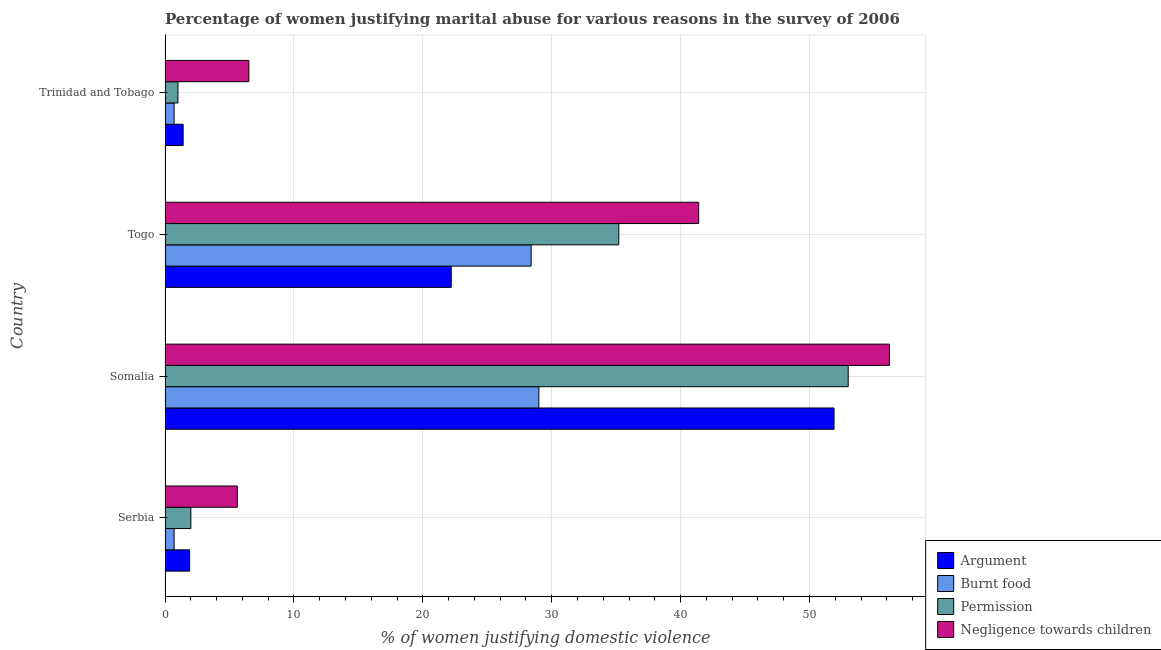How many groups of bars are there?
Keep it short and to the point. 4. How many bars are there on the 1st tick from the top?
Give a very brief answer. 4. How many bars are there on the 2nd tick from the bottom?
Your answer should be compact. 4. What is the label of the 4th group of bars from the top?
Ensure brevity in your answer.  Serbia. What is the percentage of women justifying abuse in the case of an argument in Somalia?
Offer a terse response. 51.9. Across all countries, what is the maximum percentage of women justifying abuse for burning food?
Keep it short and to the point. 29. In which country was the percentage of women justifying abuse in the case of an argument maximum?
Offer a terse response. Somalia. In which country was the percentage of women justifying abuse for showing negligence towards children minimum?
Your answer should be very brief. Serbia. What is the total percentage of women justifying abuse for showing negligence towards children in the graph?
Provide a short and direct response. 109.7. What is the difference between the percentage of women justifying abuse for burning food in Somalia and that in Trinidad and Tobago?
Provide a short and direct response. 28.3. What is the difference between the percentage of women justifying abuse for showing negligence towards children in Somalia and the percentage of women justifying abuse in the case of an argument in Togo?
Your response must be concise. 34. What is the average percentage of women justifying abuse for burning food per country?
Provide a short and direct response. 14.7. Is the percentage of women justifying abuse for going without permission in Togo less than that in Trinidad and Tobago?
Offer a very short reply. No. What is the difference between the highest and the lowest percentage of women justifying abuse in the case of an argument?
Provide a succinct answer. 50.5. In how many countries, is the percentage of women justifying abuse for showing negligence towards children greater than the average percentage of women justifying abuse for showing negligence towards children taken over all countries?
Ensure brevity in your answer.  2. Is it the case that in every country, the sum of the percentage of women justifying abuse for going without permission and percentage of women justifying abuse for burning food is greater than the sum of percentage of women justifying abuse in the case of an argument and percentage of women justifying abuse for showing negligence towards children?
Your answer should be compact. No. What does the 4th bar from the top in Trinidad and Tobago represents?
Keep it short and to the point. Argument. What does the 3rd bar from the bottom in Togo represents?
Make the answer very short. Permission. How many bars are there?
Your answer should be compact. 16. Are all the bars in the graph horizontal?
Give a very brief answer. Yes. How many countries are there in the graph?
Make the answer very short. 4. Does the graph contain any zero values?
Ensure brevity in your answer.  No. Does the graph contain grids?
Offer a terse response. Yes. What is the title of the graph?
Give a very brief answer. Percentage of women justifying marital abuse for various reasons in the survey of 2006. What is the label or title of the X-axis?
Your answer should be very brief. % of women justifying domestic violence. What is the % of women justifying domestic violence in Argument in Serbia?
Ensure brevity in your answer.  1.9. What is the % of women justifying domestic violence of Permission in Serbia?
Make the answer very short. 2. What is the % of women justifying domestic violence in Negligence towards children in Serbia?
Make the answer very short. 5.6. What is the % of women justifying domestic violence of Argument in Somalia?
Your response must be concise. 51.9. What is the % of women justifying domestic violence of Burnt food in Somalia?
Offer a terse response. 29. What is the % of women justifying domestic violence in Permission in Somalia?
Your answer should be compact. 53. What is the % of women justifying domestic violence of Negligence towards children in Somalia?
Provide a short and direct response. 56.2. What is the % of women justifying domestic violence in Burnt food in Togo?
Ensure brevity in your answer.  28.4. What is the % of women justifying domestic violence of Permission in Togo?
Offer a very short reply. 35.2. What is the % of women justifying domestic violence in Negligence towards children in Togo?
Keep it short and to the point. 41.4. What is the % of women justifying domestic violence of Argument in Trinidad and Tobago?
Your answer should be compact. 1.4. What is the % of women justifying domestic violence of Permission in Trinidad and Tobago?
Offer a very short reply. 1. What is the % of women justifying domestic violence of Negligence towards children in Trinidad and Tobago?
Your answer should be very brief. 6.5. Across all countries, what is the maximum % of women justifying domestic violence of Argument?
Make the answer very short. 51.9. Across all countries, what is the maximum % of women justifying domestic violence in Permission?
Give a very brief answer. 53. Across all countries, what is the maximum % of women justifying domestic violence in Negligence towards children?
Give a very brief answer. 56.2. Across all countries, what is the minimum % of women justifying domestic violence in Burnt food?
Offer a very short reply. 0.7. Across all countries, what is the minimum % of women justifying domestic violence of Permission?
Your answer should be very brief. 1. Across all countries, what is the minimum % of women justifying domestic violence of Negligence towards children?
Your answer should be compact. 5.6. What is the total % of women justifying domestic violence of Argument in the graph?
Your answer should be very brief. 77.4. What is the total % of women justifying domestic violence in Burnt food in the graph?
Provide a short and direct response. 58.8. What is the total % of women justifying domestic violence in Permission in the graph?
Ensure brevity in your answer.  91.2. What is the total % of women justifying domestic violence in Negligence towards children in the graph?
Your answer should be very brief. 109.7. What is the difference between the % of women justifying domestic violence in Argument in Serbia and that in Somalia?
Your answer should be compact. -50. What is the difference between the % of women justifying domestic violence in Burnt food in Serbia and that in Somalia?
Offer a terse response. -28.3. What is the difference between the % of women justifying domestic violence in Permission in Serbia and that in Somalia?
Your answer should be compact. -51. What is the difference between the % of women justifying domestic violence in Negligence towards children in Serbia and that in Somalia?
Make the answer very short. -50.6. What is the difference between the % of women justifying domestic violence of Argument in Serbia and that in Togo?
Offer a terse response. -20.3. What is the difference between the % of women justifying domestic violence in Burnt food in Serbia and that in Togo?
Your response must be concise. -27.7. What is the difference between the % of women justifying domestic violence of Permission in Serbia and that in Togo?
Offer a terse response. -33.2. What is the difference between the % of women justifying domestic violence in Negligence towards children in Serbia and that in Togo?
Provide a short and direct response. -35.8. What is the difference between the % of women justifying domestic violence in Burnt food in Serbia and that in Trinidad and Tobago?
Ensure brevity in your answer.  0. What is the difference between the % of women justifying domestic violence of Argument in Somalia and that in Togo?
Your answer should be compact. 29.7. What is the difference between the % of women justifying domestic violence of Burnt food in Somalia and that in Togo?
Offer a very short reply. 0.6. What is the difference between the % of women justifying domestic violence in Argument in Somalia and that in Trinidad and Tobago?
Provide a succinct answer. 50.5. What is the difference between the % of women justifying domestic violence in Burnt food in Somalia and that in Trinidad and Tobago?
Keep it short and to the point. 28.3. What is the difference between the % of women justifying domestic violence of Negligence towards children in Somalia and that in Trinidad and Tobago?
Give a very brief answer. 49.7. What is the difference between the % of women justifying domestic violence of Argument in Togo and that in Trinidad and Tobago?
Give a very brief answer. 20.8. What is the difference between the % of women justifying domestic violence in Burnt food in Togo and that in Trinidad and Tobago?
Give a very brief answer. 27.7. What is the difference between the % of women justifying domestic violence of Permission in Togo and that in Trinidad and Tobago?
Your answer should be very brief. 34.2. What is the difference between the % of women justifying domestic violence in Negligence towards children in Togo and that in Trinidad and Tobago?
Keep it short and to the point. 34.9. What is the difference between the % of women justifying domestic violence in Argument in Serbia and the % of women justifying domestic violence in Burnt food in Somalia?
Your answer should be very brief. -27.1. What is the difference between the % of women justifying domestic violence of Argument in Serbia and the % of women justifying domestic violence of Permission in Somalia?
Provide a short and direct response. -51.1. What is the difference between the % of women justifying domestic violence in Argument in Serbia and the % of women justifying domestic violence in Negligence towards children in Somalia?
Your answer should be very brief. -54.3. What is the difference between the % of women justifying domestic violence in Burnt food in Serbia and the % of women justifying domestic violence in Permission in Somalia?
Make the answer very short. -52.3. What is the difference between the % of women justifying domestic violence in Burnt food in Serbia and the % of women justifying domestic violence in Negligence towards children in Somalia?
Provide a succinct answer. -55.5. What is the difference between the % of women justifying domestic violence in Permission in Serbia and the % of women justifying domestic violence in Negligence towards children in Somalia?
Offer a terse response. -54.2. What is the difference between the % of women justifying domestic violence in Argument in Serbia and the % of women justifying domestic violence in Burnt food in Togo?
Ensure brevity in your answer.  -26.5. What is the difference between the % of women justifying domestic violence of Argument in Serbia and the % of women justifying domestic violence of Permission in Togo?
Your answer should be very brief. -33.3. What is the difference between the % of women justifying domestic violence of Argument in Serbia and the % of women justifying domestic violence of Negligence towards children in Togo?
Your response must be concise. -39.5. What is the difference between the % of women justifying domestic violence of Burnt food in Serbia and the % of women justifying domestic violence of Permission in Togo?
Ensure brevity in your answer.  -34.5. What is the difference between the % of women justifying domestic violence in Burnt food in Serbia and the % of women justifying domestic violence in Negligence towards children in Togo?
Your answer should be compact. -40.7. What is the difference between the % of women justifying domestic violence in Permission in Serbia and the % of women justifying domestic violence in Negligence towards children in Togo?
Your response must be concise. -39.4. What is the difference between the % of women justifying domestic violence in Argument in Serbia and the % of women justifying domestic violence in Negligence towards children in Trinidad and Tobago?
Provide a short and direct response. -4.6. What is the difference between the % of women justifying domestic violence in Argument in Somalia and the % of women justifying domestic violence in Burnt food in Togo?
Provide a succinct answer. 23.5. What is the difference between the % of women justifying domestic violence in Argument in Somalia and the % of women justifying domestic violence in Permission in Togo?
Offer a terse response. 16.7. What is the difference between the % of women justifying domestic violence in Burnt food in Somalia and the % of women justifying domestic violence in Permission in Togo?
Provide a short and direct response. -6.2. What is the difference between the % of women justifying domestic violence in Burnt food in Somalia and the % of women justifying domestic violence in Negligence towards children in Togo?
Offer a terse response. -12.4. What is the difference between the % of women justifying domestic violence of Permission in Somalia and the % of women justifying domestic violence of Negligence towards children in Togo?
Ensure brevity in your answer.  11.6. What is the difference between the % of women justifying domestic violence in Argument in Somalia and the % of women justifying domestic violence in Burnt food in Trinidad and Tobago?
Provide a succinct answer. 51.2. What is the difference between the % of women justifying domestic violence of Argument in Somalia and the % of women justifying domestic violence of Permission in Trinidad and Tobago?
Provide a short and direct response. 50.9. What is the difference between the % of women justifying domestic violence of Argument in Somalia and the % of women justifying domestic violence of Negligence towards children in Trinidad and Tobago?
Keep it short and to the point. 45.4. What is the difference between the % of women justifying domestic violence in Burnt food in Somalia and the % of women justifying domestic violence in Permission in Trinidad and Tobago?
Offer a terse response. 28. What is the difference between the % of women justifying domestic violence of Permission in Somalia and the % of women justifying domestic violence of Negligence towards children in Trinidad and Tobago?
Offer a terse response. 46.5. What is the difference between the % of women justifying domestic violence of Argument in Togo and the % of women justifying domestic violence of Permission in Trinidad and Tobago?
Give a very brief answer. 21.2. What is the difference between the % of women justifying domestic violence in Burnt food in Togo and the % of women justifying domestic violence in Permission in Trinidad and Tobago?
Your answer should be compact. 27.4. What is the difference between the % of women justifying domestic violence of Burnt food in Togo and the % of women justifying domestic violence of Negligence towards children in Trinidad and Tobago?
Your response must be concise. 21.9. What is the difference between the % of women justifying domestic violence of Permission in Togo and the % of women justifying domestic violence of Negligence towards children in Trinidad and Tobago?
Your answer should be compact. 28.7. What is the average % of women justifying domestic violence of Argument per country?
Provide a short and direct response. 19.35. What is the average % of women justifying domestic violence in Permission per country?
Your answer should be very brief. 22.8. What is the average % of women justifying domestic violence of Negligence towards children per country?
Keep it short and to the point. 27.43. What is the difference between the % of women justifying domestic violence of Permission and % of women justifying domestic violence of Negligence towards children in Serbia?
Ensure brevity in your answer.  -3.6. What is the difference between the % of women justifying domestic violence in Argument and % of women justifying domestic violence in Burnt food in Somalia?
Keep it short and to the point. 22.9. What is the difference between the % of women justifying domestic violence in Argument and % of women justifying domestic violence in Permission in Somalia?
Provide a succinct answer. -1.1. What is the difference between the % of women justifying domestic violence of Burnt food and % of women justifying domestic violence of Negligence towards children in Somalia?
Ensure brevity in your answer.  -27.2. What is the difference between the % of women justifying domestic violence of Permission and % of women justifying domestic violence of Negligence towards children in Somalia?
Ensure brevity in your answer.  -3.2. What is the difference between the % of women justifying domestic violence of Argument and % of women justifying domestic violence of Burnt food in Togo?
Offer a very short reply. -6.2. What is the difference between the % of women justifying domestic violence of Argument and % of women justifying domestic violence of Negligence towards children in Togo?
Ensure brevity in your answer.  -19.2. What is the difference between the % of women justifying domestic violence in Burnt food and % of women justifying domestic violence in Permission in Togo?
Your response must be concise. -6.8. What is the difference between the % of women justifying domestic violence of Burnt food and % of women justifying domestic violence of Negligence towards children in Togo?
Provide a short and direct response. -13. What is the difference between the % of women justifying domestic violence in Permission and % of women justifying domestic violence in Negligence towards children in Togo?
Your answer should be very brief. -6.2. What is the difference between the % of women justifying domestic violence of Argument and % of women justifying domestic violence of Burnt food in Trinidad and Tobago?
Give a very brief answer. 0.7. What is the difference between the % of women justifying domestic violence in Argument and % of women justifying domestic violence in Permission in Trinidad and Tobago?
Give a very brief answer. 0.4. What is the difference between the % of women justifying domestic violence in Permission and % of women justifying domestic violence in Negligence towards children in Trinidad and Tobago?
Provide a succinct answer. -5.5. What is the ratio of the % of women justifying domestic violence in Argument in Serbia to that in Somalia?
Offer a terse response. 0.04. What is the ratio of the % of women justifying domestic violence in Burnt food in Serbia to that in Somalia?
Ensure brevity in your answer.  0.02. What is the ratio of the % of women justifying domestic violence of Permission in Serbia to that in Somalia?
Your answer should be compact. 0.04. What is the ratio of the % of women justifying domestic violence in Negligence towards children in Serbia to that in Somalia?
Provide a short and direct response. 0.1. What is the ratio of the % of women justifying domestic violence in Argument in Serbia to that in Togo?
Provide a short and direct response. 0.09. What is the ratio of the % of women justifying domestic violence in Burnt food in Serbia to that in Togo?
Your answer should be very brief. 0.02. What is the ratio of the % of women justifying domestic violence of Permission in Serbia to that in Togo?
Provide a short and direct response. 0.06. What is the ratio of the % of women justifying domestic violence in Negligence towards children in Serbia to that in Togo?
Make the answer very short. 0.14. What is the ratio of the % of women justifying domestic violence in Argument in Serbia to that in Trinidad and Tobago?
Your answer should be compact. 1.36. What is the ratio of the % of women justifying domestic violence in Permission in Serbia to that in Trinidad and Tobago?
Offer a terse response. 2. What is the ratio of the % of women justifying domestic violence in Negligence towards children in Serbia to that in Trinidad and Tobago?
Provide a succinct answer. 0.86. What is the ratio of the % of women justifying domestic violence of Argument in Somalia to that in Togo?
Offer a very short reply. 2.34. What is the ratio of the % of women justifying domestic violence of Burnt food in Somalia to that in Togo?
Give a very brief answer. 1.02. What is the ratio of the % of women justifying domestic violence in Permission in Somalia to that in Togo?
Keep it short and to the point. 1.51. What is the ratio of the % of women justifying domestic violence of Negligence towards children in Somalia to that in Togo?
Keep it short and to the point. 1.36. What is the ratio of the % of women justifying domestic violence of Argument in Somalia to that in Trinidad and Tobago?
Your answer should be compact. 37.07. What is the ratio of the % of women justifying domestic violence in Burnt food in Somalia to that in Trinidad and Tobago?
Provide a short and direct response. 41.43. What is the ratio of the % of women justifying domestic violence of Negligence towards children in Somalia to that in Trinidad and Tobago?
Offer a terse response. 8.65. What is the ratio of the % of women justifying domestic violence in Argument in Togo to that in Trinidad and Tobago?
Provide a short and direct response. 15.86. What is the ratio of the % of women justifying domestic violence in Burnt food in Togo to that in Trinidad and Tobago?
Your response must be concise. 40.57. What is the ratio of the % of women justifying domestic violence in Permission in Togo to that in Trinidad and Tobago?
Give a very brief answer. 35.2. What is the ratio of the % of women justifying domestic violence in Negligence towards children in Togo to that in Trinidad and Tobago?
Offer a very short reply. 6.37. What is the difference between the highest and the second highest % of women justifying domestic violence of Argument?
Provide a succinct answer. 29.7. What is the difference between the highest and the second highest % of women justifying domestic violence of Negligence towards children?
Keep it short and to the point. 14.8. What is the difference between the highest and the lowest % of women justifying domestic violence of Argument?
Make the answer very short. 50.5. What is the difference between the highest and the lowest % of women justifying domestic violence of Burnt food?
Ensure brevity in your answer.  28.3. What is the difference between the highest and the lowest % of women justifying domestic violence in Negligence towards children?
Your answer should be very brief. 50.6. 